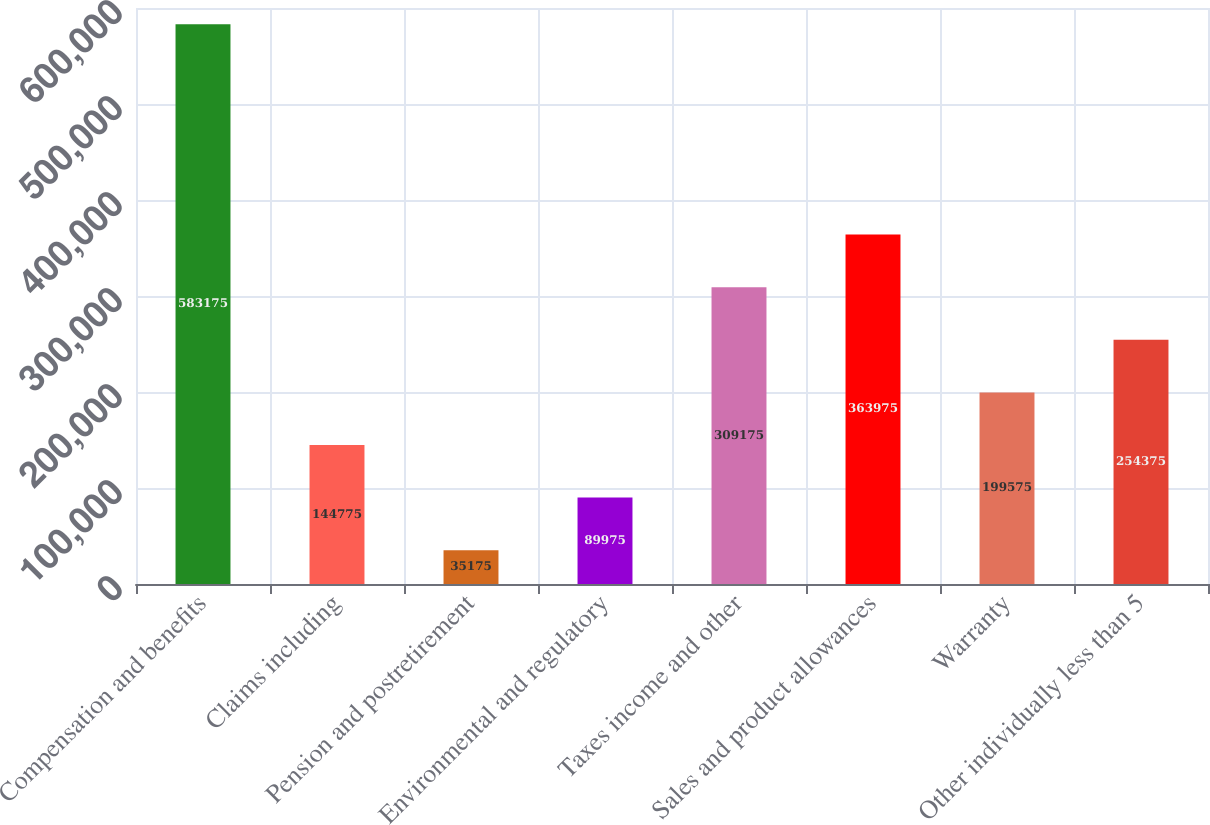Convert chart. <chart><loc_0><loc_0><loc_500><loc_500><bar_chart><fcel>Compensation and benefits<fcel>Claims including<fcel>Pension and postretirement<fcel>Environmental and regulatory<fcel>Taxes income and other<fcel>Sales and product allowances<fcel>Warranty<fcel>Other individually less than 5<nl><fcel>583175<fcel>144775<fcel>35175<fcel>89975<fcel>309175<fcel>363975<fcel>199575<fcel>254375<nl></chart> 